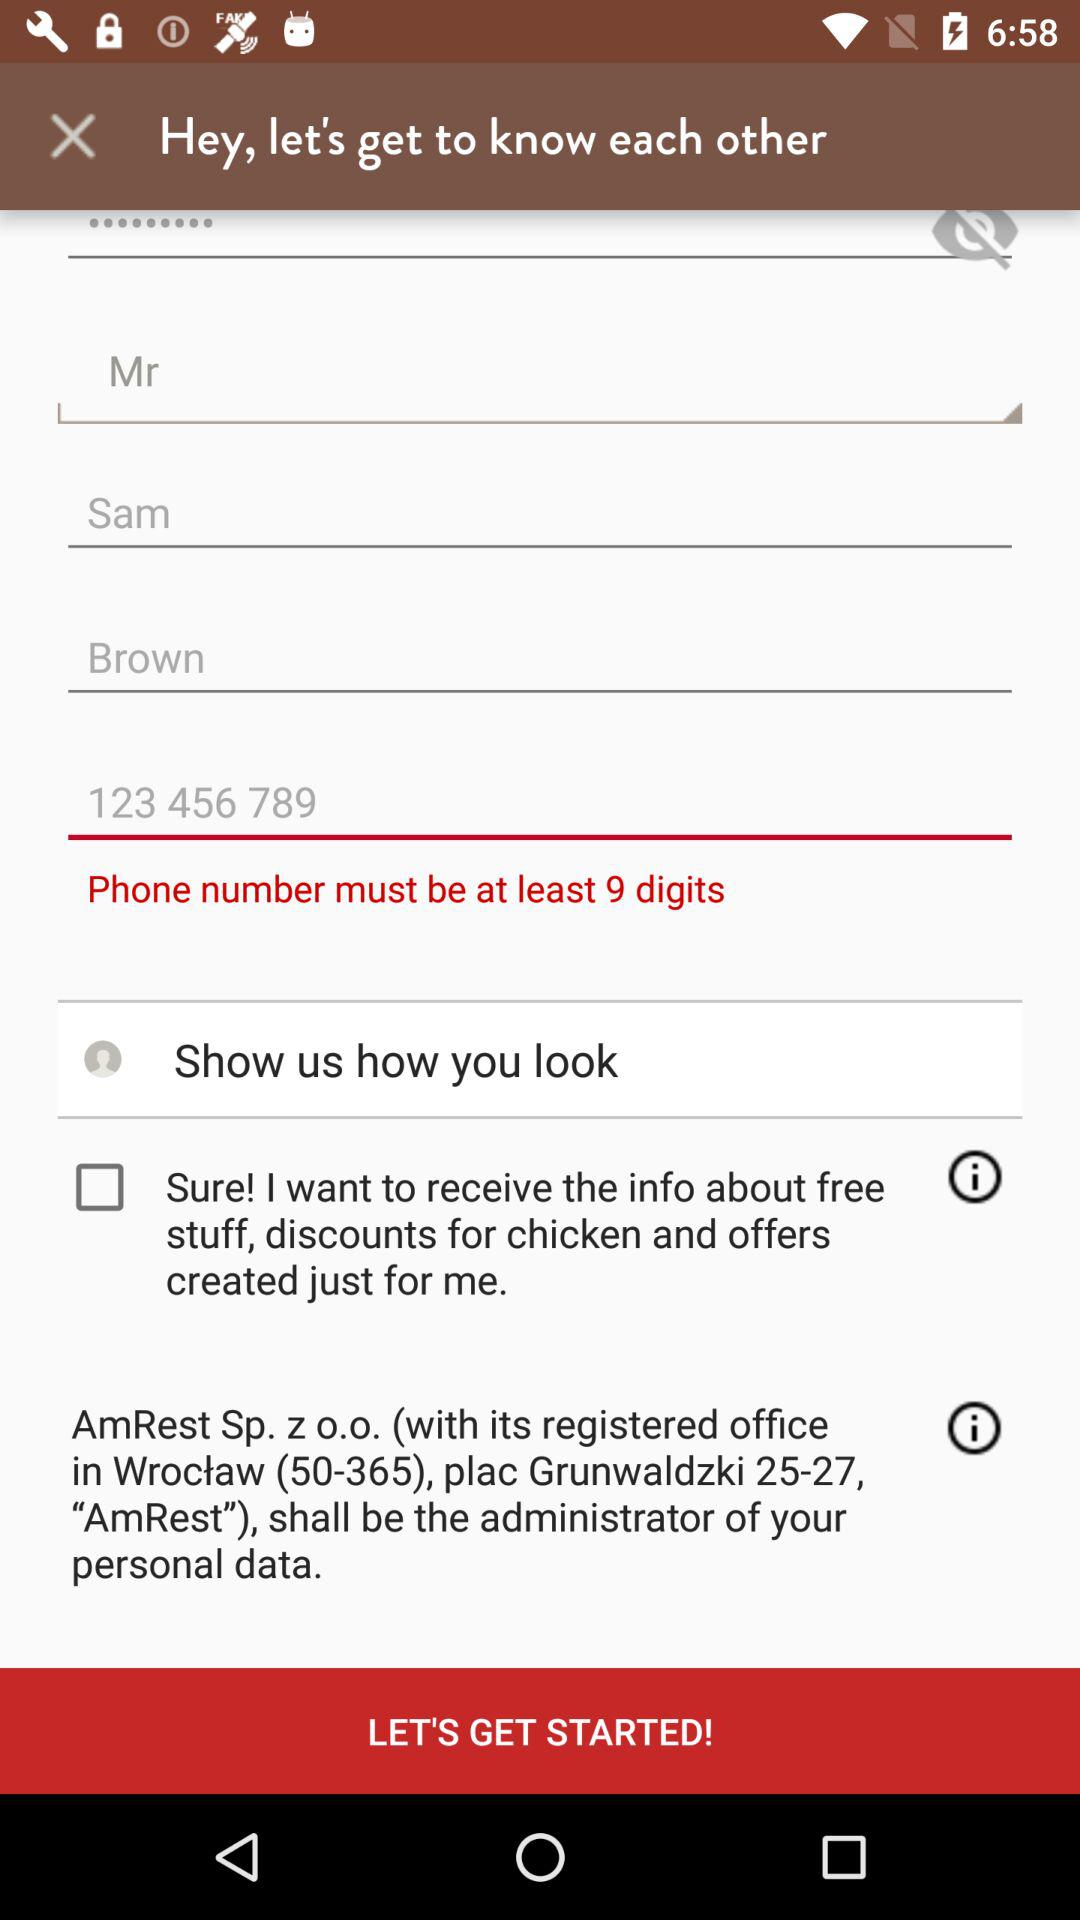How many text inputs are on the second row?
Answer the question using a single word or phrase. 3 